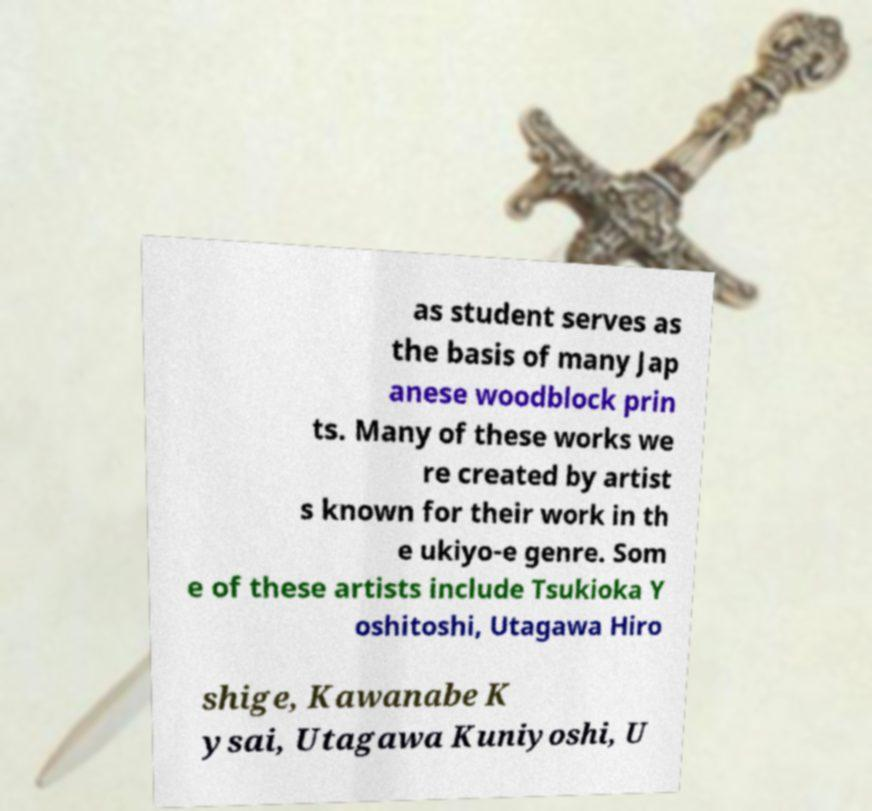Please read and relay the text visible in this image. What does it say? as student serves as the basis of many Jap anese woodblock prin ts. Many of these works we re created by artist s known for their work in th e ukiyo-e genre. Som e of these artists include Tsukioka Y oshitoshi, Utagawa Hiro shige, Kawanabe K ysai, Utagawa Kuniyoshi, U 